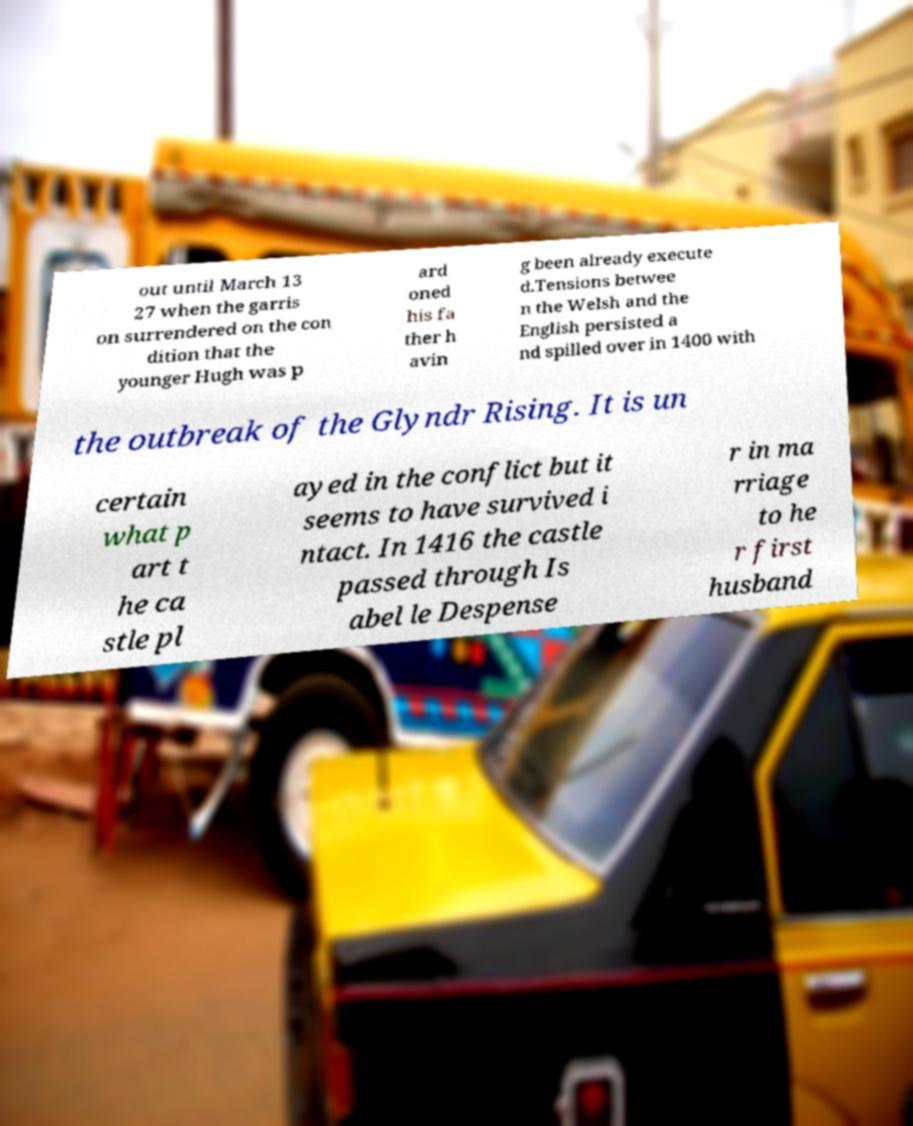For documentation purposes, I need the text within this image transcribed. Could you provide that? out until March 13 27 when the garris on surrendered on the con dition that the younger Hugh was p ard oned his fa ther h avin g been already execute d.Tensions betwee n the Welsh and the English persisted a nd spilled over in 1400 with the outbreak of the Glyndr Rising. It is un certain what p art t he ca stle pl ayed in the conflict but it seems to have survived i ntact. In 1416 the castle passed through Is abel le Despense r in ma rriage to he r first husband 